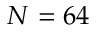<formula> <loc_0><loc_0><loc_500><loc_500>N = 6 4</formula> 